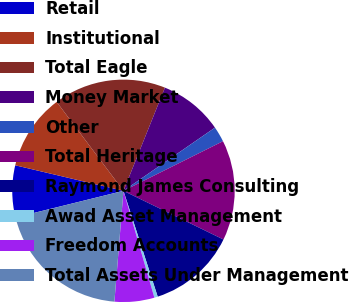Convert chart. <chart><loc_0><loc_0><loc_500><loc_500><pie_chart><fcel>Retail<fcel>Institutional<fcel>Total Eagle<fcel>Money Market<fcel>Other<fcel>Total Heritage<fcel>Raymond James Consulting<fcel>Awad Asset Management<fcel>Freedom Accounts<fcel>Total Assets Under Management<nl><fcel>7.54%<fcel>11.06%<fcel>16.33%<fcel>9.3%<fcel>2.26%<fcel>14.57%<fcel>12.81%<fcel>0.5%<fcel>5.78%<fcel>19.85%<nl></chart> 